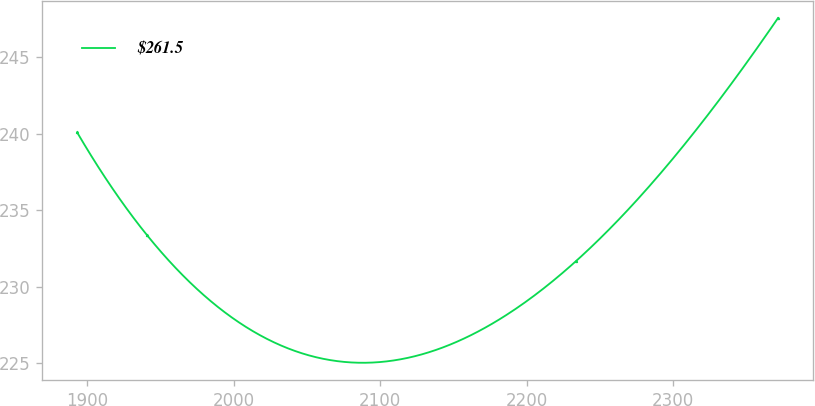Convert chart to OTSL. <chart><loc_0><loc_0><loc_500><loc_500><line_chart><ecel><fcel>$261.5<nl><fcel>1893.19<fcel>240.07<nl><fcel>1941.01<fcel>233.34<nl><fcel>2233.56<fcel>231.66<nl><fcel>2371.37<fcel>247.54<nl></chart> 